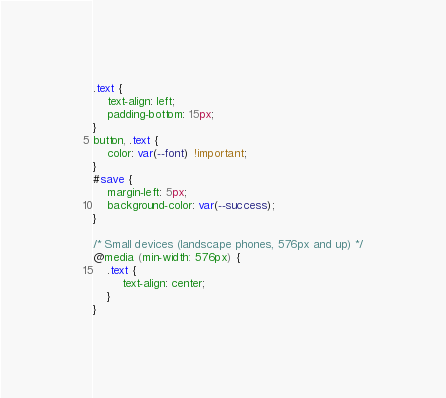Convert code to text. <code><loc_0><loc_0><loc_500><loc_500><_CSS_>.text {
    text-align: left;
    padding-bottom: 15px;
}
button, .text {
    color: var(--font) !important;    
}
#save {
    margin-left: 5px;
    background-color: var(--success);
}

/* Small devices (landscape phones, 576px and up) */
@media (min-width: 576px) {
    .text {
        text-align: center;
    }
}</code> 